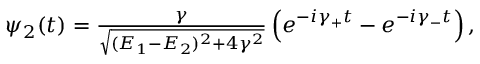Convert formula to latex. <formula><loc_0><loc_0><loc_500><loc_500>\begin{array} { r } { \psi _ { 2 } ( t ) = \frac { \gamma } { \sqrt { ( E _ { 1 } - E _ { 2 } ) ^ { 2 } + 4 \gamma ^ { 2 } } } \left ( e ^ { - i \gamma _ { + } t } - e ^ { - i \gamma _ { - } t } \right ) , } \end{array}</formula> 